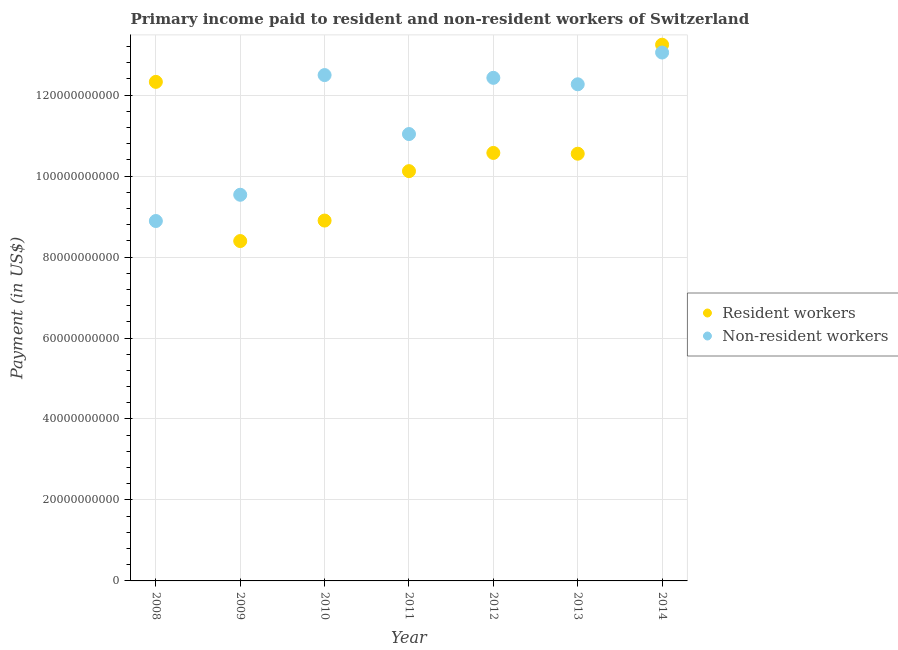What is the payment made to non-resident workers in 2013?
Provide a short and direct response. 1.23e+11. Across all years, what is the maximum payment made to resident workers?
Provide a short and direct response. 1.32e+11. Across all years, what is the minimum payment made to non-resident workers?
Offer a terse response. 8.89e+1. In which year was the payment made to non-resident workers minimum?
Make the answer very short. 2008. What is the total payment made to resident workers in the graph?
Ensure brevity in your answer.  7.41e+11. What is the difference between the payment made to non-resident workers in 2011 and that in 2012?
Your response must be concise. -1.39e+1. What is the difference between the payment made to resident workers in 2011 and the payment made to non-resident workers in 2012?
Your answer should be very brief. -2.31e+1. What is the average payment made to resident workers per year?
Provide a short and direct response. 1.06e+11. In the year 2011, what is the difference between the payment made to resident workers and payment made to non-resident workers?
Make the answer very short. -9.16e+09. What is the ratio of the payment made to resident workers in 2011 to that in 2012?
Keep it short and to the point. 0.96. Is the payment made to resident workers in 2013 less than that in 2014?
Offer a terse response. Yes. What is the difference between the highest and the second highest payment made to non-resident workers?
Offer a very short reply. 5.57e+09. What is the difference between the highest and the lowest payment made to resident workers?
Provide a succinct answer. 4.85e+1. Does the payment made to resident workers monotonically increase over the years?
Your response must be concise. No. How many years are there in the graph?
Your answer should be very brief. 7. Are the values on the major ticks of Y-axis written in scientific E-notation?
Ensure brevity in your answer.  No. What is the title of the graph?
Your response must be concise. Primary income paid to resident and non-resident workers of Switzerland. Does "National Visitors" appear as one of the legend labels in the graph?
Your answer should be compact. No. What is the label or title of the X-axis?
Provide a succinct answer. Year. What is the label or title of the Y-axis?
Provide a short and direct response. Payment (in US$). What is the Payment (in US$) of Resident workers in 2008?
Ensure brevity in your answer.  1.23e+11. What is the Payment (in US$) in Non-resident workers in 2008?
Offer a very short reply. 8.89e+1. What is the Payment (in US$) in Resident workers in 2009?
Make the answer very short. 8.40e+1. What is the Payment (in US$) of Non-resident workers in 2009?
Keep it short and to the point. 9.54e+1. What is the Payment (in US$) in Resident workers in 2010?
Ensure brevity in your answer.  8.90e+1. What is the Payment (in US$) in Non-resident workers in 2010?
Give a very brief answer. 1.25e+11. What is the Payment (in US$) in Resident workers in 2011?
Your response must be concise. 1.01e+11. What is the Payment (in US$) of Non-resident workers in 2011?
Provide a succinct answer. 1.10e+11. What is the Payment (in US$) of Resident workers in 2012?
Provide a succinct answer. 1.06e+11. What is the Payment (in US$) in Non-resident workers in 2012?
Keep it short and to the point. 1.24e+11. What is the Payment (in US$) in Resident workers in 2013?
Your response must be concise. 1.06e+11. What is the Payment (in US$) of Non-resident workers in 2013?
Ensure brevity in your answer.  1.23e+11. What is the Payment (in US$) in Resident workers in 2014?
Your answer should be compact. 1.32e+11. What is the Payment (in US$) of Non-resident workers in 2014?
Keep it short and to the point. 1.31e+11. Across all years, what is the maximum Payment (in US$) of Resident workers?
Provide a short and direct response. 1.32e+11. Across all years, what is the maximum Payment (in US$) of Non-resident workers?
Your response must be concise. 1.31e+11. Across all years, what is the minimum Payment (in US$) of Resident workers?
Ensure brevity in your answer.  8.40e+1. Across all years, what is the minimum Payment (in US$) of Non-resident workers?
Keep it short and to the point. 8.89e+1. What is the total Payment (in US$) in Resident workers in the graph?
Give a very brief answer. 7.41e+11. What is the total Payment (in US$) of Non-resident workers in the graph?
Provide a succinct answer. 7.97e+11. What is the difference between the Payment (in US$) in Resident workers in 2008 and that in 2009?
Your response must be concise. 3.93e+1. What is the difference between the Payment (in US$) in Non-resident workers in 2008 and that in 2009?
Keep it short and to the point. -6.48e+09. What is the difference between the Payment (in US$) of Resident workers in 2008 and that in 2010?
Your answer should be compact. 3.43e+1. What is the difference between the Payment (in US$) of Non-resident workers in 2008 and that in 2010?
Offer a terse response. -3.60e+1. What is the difference between the Payment (in US$) of Resident workers in 2008 and that in 2011?
Make the answer very short. 2.21e+1. What is the difference between the Payment (in US$) of Non-resident workers in 2008 and that in 2011?
Provide a short and direct response. -2.15e+1. What is the difference between the Payment (in US$) of Resident workers in 2008 and that in 2012?
Your response must be concise. 1.76e+1. What is the difference between the Payment (in US$) of Non-resident workers in 2008 and that in 2012?
Provide a short and direct response. -3.54e+1. What is the difference between the Payment (in US$) of Resident workers in 2008 and that in 2013?
Your answer should be compact. 1.77e+1. What is the difference between the Payment (in US$) in Non-resident workers in 2008 and that in 2013?
Your answer should be compact. -3.38e+1. What is the difference between the Payment (in US$) of Resident workers in 2008 and that in 2014?
Offer a very short reply. -9.18e+09. What is the difference between the Payment (in US$) in Non-resident workers in 2008 and that in 2014?
Your answer should be compact. -4.16e+1. What is the difference between the Payment (in US$) in Resident workers in 2009 and that in 2010?
Provide a succinct answer. -5.06e+09. What is the difference between the Payment (in US$) of Non-resident workers in 2009 and that in 2010?
Your response must be concise. -2.96e+1. What is the difference between the Payment (in US$) of Resident workers in 2009 and that in 2011?
Provide a short and direct response. -1.73e+1. What is the difference between the Payment (in US$) in Non-resident workers in 2009 and that in 2011?
Offer a very short reply. -1.50e+1. What is the difference between the Payment (in US$) of Resident workers in 2009 and that in 2012?
Keep it short and to the point. -2.18e+1. What is the difference between the Payment (in US$) in Non-resident workers in 2009 and that in 2012?
Provide a short and direct response. -2.89e+1. What is the difference between the Payment (in US$) in Resident workers in 2009 and that in 2013?
Ensure brevity in your answer.  -2.16e+1. What is the difference between the Payment (in US$) of Non-resident workers in 2009 and that in 2013?
Keep it short and to the point. -2.73e+1. What is the difference between the Payment (in US$) in Resident workers in 2009 and that in 2014?
Your response must be concise. -4.85e+1. What is the difference between the Payment (in US$) in Non-resident workers in 2009 and that in 2014?
Keep it short and to the point. -3.51e+1. What is the difference between the Payment (in US$) in Resident workers in 2010 and that in 2011?
Your answer should be very brief. -1.22e+1. What is the difference between the Payment (in US$) in Non-resident workers in 2010 and that in 2011?
Your answer should be compact. 1.46e+1. What is the difference between the Payment (in US$) in Resident workers in 2010 and that in 2012?
Keep it short and to the point. -1.67e+1. What is the difference between the Payment (in US$) of Non-resident workers in 2010 and that in 2012?
Provide a succinct answer. 6.81e+08. What is the difference between the Payment (in US$) of Resident workers in 2010 and that in 2013?
Provide a succinct answer. -1.65e+1. What is the difference between the Payment (in US$) in Non-resident workers in 2010 and that in 2013?
Keep it short and to the point. 2.28e+09. What is the difference between the Payment (in US$) in Resident workers in 2010 and that in 2014?
Give a very brief answer. -4.34e+1. What is the difference between the Payment (in US$) of Non-resident workers in 2010 and that in 2014?
Provide a short and direct response. -5.57e+09. What is the difference between the Payment (in US$) in Resident workers in 2011 and that in 2012?
Ensure brevity in your answer.  -4.50e+09. What is the difference between the Payment (in US$) of Non-resident workers in 2011 and that in 2012?
Offer a very short reply. -1.39e+1. What is the difference between the Payment (in US$) in Resident workers in 2011 and that in 2013?
Your answer should be compact. -4.31e+09. What is the difference between the Payment (in US$) of Non-resident workers in 2011 and that in 2013?
Offer a terse response. -1.23e+1. What is the difference between the Payment (in US$) in Resident workers in 2011 and that in 2014?
Your answer should be very brief. -3.12e+1. What is the difference between the Payment (in US$) in Non-resident workers in 2011 and that in 2014?
Make the answer very short. -2.01e+1. What is the difference between the Payment (in US$) in Resident workers in 2012 and that in 2013?
Your answer should be very brief. 1.92e+08. What is the difference between the Payment (in US$) of Non-resident workers in 2012 and that in 2013?
Provide a short and direct response. 1.60e+09. What is the difference between the Payment (in US$) of Resident workers in 2012 and that in 2014?
Provide a succinct answer. -2.67e+1. What is the difference between the Payment (in US$) in Non-resident workers in 2012 and that in 2014?
Offer a very short reply. -6.25e+09. What is the difference between the Payment (in US$) of Resident workers in 2013 and that in 2014?
Offer a very short reply. -2.69e+1. What is the difference between the Payment (in US$) of Non-resident workers in 2013 and that in 2014?
Make the answer very short. -7.84e+09. What is the difference between the Payment (in US$) of Resident workers in 2008 and the Payment (in US$) of Non-resident workers in 2009?
Provide a succinct answer. 2.79e+1. What is the difference between the Payment (in US$) in Resident workers in 2008 and the Payment (in US$) in Non-resident workers in 2010?
Provide a succinct answer. -1.68e+09. What is the difference between the Payment (in US$) in Resident workers in 2008 and the Payment (in US$) in Non-resident workers in 2011?
Give a very brief answer. 1.29e+1. What is the difference between the Payment (in US$) of Resident workers in 2008 and the Payment (in US$) of Non-resident workers in 2012?
Ensure brevity in your answer.  -9.99e+08. What is the difference between the Payment (in US$) of Resident workers in 2008 and the Payment (in US$) of Non-resident workers in 2013?
Provide a succinct answer. 5.97e+08. What is the difference between the Payment (in US$) of Resident workers in 2008 and the Payment (in US$) of Non-resident workers in 2014?
Your answer should be very brief. -7.25e+09. What is the difference between the Payment (in US$) in Resident workers in 2009 and the Payment (in US$) in Non-resident workers in 2010?
Provide a short and direct response. -4.10e+1. What is the difference between the Payment (in US$) in Resident workers in 2009 and the Payment (in US$) in Non-resident workers in 2011?
Ensure brevity in your answer.  -2.64e+1. What is the difference between the Payment (in US$) in Resident workers in 2009 and the Payment (in US$) in Non-resident workers in 2012?
Provide a succinct answer. -4.03e+1. What is the difference between the Payment (in US$) of Resident workers in 2009 and the Payment (in US$) of Non-resident workers in 2013?
Offer a very short reply. -3.87e+1. What is the difference between the Payment (in US$) of Resident workers in 2009 and the Payment (in US$) of Non-resident workers in 2014?
Provide a succinct answer. -4.66e+1. What is the difference between the Payment (in US$) in Resident workers in 2010 and the Payment (in US$) in Non-resident workers in 2011?
Keep it short and to the point. -2.14e+1. What is the difference between the Payment (in US$) of Resident workers in 2010 and the Payment (in US$) of Non-resident workers in 2012?
Offer a very short reply. -3.53e+1. What is the difference between the Payment (in US$) in Resident workers in 2010 and the Payment (in US$) in Non-resident workers in 2013?
Offer a very short reply. -3.37e+1. What is the difference between the Payment (in US$) in Resident workers in 2010 and the Payment (in US$) in Non-resident workers in 2014?
Your response must be concise. -4.15e+1. What is the difference between the Payment (in US$) of Resident workers in 2011 and the Payment (in US$) of Non-resident workers in 2012?
Your answer should be very brief. -2.31e+1. What is the difference between the Payment (in US$) of Resident workers in 2011 and the Payment (in US$) of Non-resident workers in 2013?
Your answer should be very brief. -2.15e+1. What is the difference between the Payment (in US$) of Resident workers in 2011 and the Payment (in US$) of Non-resident workers in 2014?
Ensure brevity in your answer.  -2.93e+1. What is the difference between the Payment (in US$) in Resident workers in 2012 and the Payment (in US$) in Non-resident workers in 2013?
Your answer should be compact. -1.70e+1. What is the difference between the Payment (in US$) in Resident workers in 2012 and the Payment (in US$) in Non-resident workers in 2014?
Ensure brevity in your answer.  -2.48e+1. What is the difference between the Payment (in US$) in Resident workers in 2013 and the Payment (in US$) in Non-resident workers in 2014?
Keep it short and to the point. -2.50e+1. What is the average Payment (in US$) in Resident workers per year?
Your answer should be very brief. 1.06e+11. What is the average Payment (in US$) in Non-resident workers per year?
Give a very brief answer. 1.14e+11. In the year 2008, what is the difference between the Payment (in US$) in Resident workers and Payment (in US$) in Non-resident workers?
Make the answer very short. 3.44e+1. In the year 2009, what is the difference between the Payment (in US$) in Resident workers and Payment (in US$) in Non-resident workers?
Provide a short and direct response. -1.14e+1. In the year 2010, what is the difference between the Payment (in US$) in Resident workers and Payment (in US$) in Non-resident workers?
Offer a very short reply. -3.59e+1. In the year 2011, what is the difference between the Payment (in US$) of Resident workers and Payment (in US$) of Non-resident workers?
Make the answer very short. -9.16e+09. In the year 2012, what is the difference between the Payment (in US$) of Resident workers and Payment (in US$) of Non-resident workers?
Offer a terse response. -1.86e+1. In the year 2013, what is the difference between the Payment (in US$) of Resident workers and Payment (in US$) of Non-resident workers?
Your answer should be very brief. -1.71e+1. In the year 2014, what is the difference between the Payment (in US$) in Resident workers and Payment (in US$) in Non-resident workers?
Provide a succinct answer. 1.94e+09. What is the ratio of the Payment (in US$) of Resident workers in 2008 to that in 2009?
Ensure brevity in your answer.  1.47. What is the ratio of the Payment (in US$) in Non-resident workers in 2008 to that in 2009?
Provide a succinct answer. 0.93. What is the ratio of the Payment (in US$) of Resident workers in 2008 to that in 2010?
Make the answer very short. 1.38. What is the ratio of the Payment (in US$) in Non-resident workers in 2008 to that in 2010?
Your answer should be very brief. 0.71. What is the ratio of the Payment (in US$) of Resident workers in 2008 to that in 2011?
Ensure brevity in your answer.  1.22. What is the ratio of the Payment (in US$) of Non-resident workers in 2008 to that in 2011?
Make the answer very short. 0.81. What is the ratio of the Payment (in US$) of Resident workers in 2008 to that in 2012?
Make the answer very short. 1.17. What is the ratio of the Payment (in US$) in Non-resident workers in 2008 to that in 2012?
Keep it short and to the point. 0.72. What is the ratio of the Payment (in US$) in Resident workers in 2008 to that in 2013?
Keep it short and to the point. 1.17. What is the ratio of the Payment (in US$) of Non-resident workers in 2008 to that in 2013?
Provide a short and direct response. 0.72. What is the ratio of the Payment (in US$) of Resident workers in 2008 to that in 2014?
Make the answer very short. 0.93. What is the ratio of the Payment (in US$) of Non-resident workers in 2008 to that in 2014?
Offer a very short reply. 0.68. What is the ratio of the Payment (in US$) of Resident workers in 2009 to that in 2010?
Provide a succinct answer. 0.94. What is the ratio of the Payment (in US$) of Non-resident workers in 2009 to that in 2010?
Make the answer very short. 0.76. What is the ratio of the Payment (in US$) in Resident workers in 2009 to that in 2011?
Ensure brevity in your answer.  0.83. What is the ratio of the Payment (in US$) in Non-resident workers in 2009 to that in 2011?
Give a very brief answer. 0.86. What is the ratio of the Payment (in US$) in Resident workers in 2009 to that in 2012?
Offer a very short reply. 0.79. What is the ratio of the Payment (in US$) in Non-resident workers in 2009 to that in 2012?
Give a very brief answer. 0.77. What is the ratio of the Payment (in US$) of Resident workers in 2009 to that in 2013?
Make the answer very short. 0.8. What is the ratio of the Payment (in US$) of Non-resident workers in 2009 to that in 2013?
Provide a short and direct response. 0.78. What is the ratio of the Payment (in US$) of Resident workers in 2009 to that in 2014?
Provide a succinct answer. 0.63. What is the ratio of the Payment (in US$) in Non-resident workers in 2009 to that in 2014?
Give a very brief answer. 0.73. What is the ratio of the Payment (in US$) in Resident workers in 2010 to that in 2011?
Offer a terse response. 0.88. What is the ratio of the Payment (in US$) of Non-resident workers in 2010 to that in 2011?
Provide a short and direct response. 1.13. What is the ratio of the Payment (in US$) of Resident workers in 2010 to that in 2012?
Ensure brevity in your answer.  0.84. What is the ratio of the Payment (in US$) in Non-resident workers in 2010 to that in 2012?
Keep it short and to the point. 1.01. What is the ratio of the Payment (in US$) in Resident workers in 2010 to that in 2013?
Provide a succinct answer. 0.84. What is the ratio of the Payment (in US$) of Non-resident workers in 2010 to that in 2013?
Ensure brevity in your answer.  1.02. What is the ratio of the Payment (in US$) in Resident workers in 2010 to that in 2014?
Keep it short and to the point. 0.67. What is the ratio of the Payment (in US$) in Non-resident workers in 2010 to that in 2014?
Give a very brief answer. 0.96. What is the ratio of the Payment (in US$) in Resident workers in 2011 to that in 2012?
Make the answer very short. 0.96. What is the ratio of the Payment (in US$) in Non-resident workers in 2011 to that in 2012?
Provide a short and direct response. 0.89. What is the ratio of the Payment (in US$) in Resident workers in 2011 to that in 2013?
Your response must be concise. 0.96. What is the ratio of the Payment (in US$) in Non-resident workers in 2011 to that in 2013?
Provide a short and direct response. 0.9. What is the ratio of the Payment (in US$) of Resident workers in 2011 to that in 2014?
Give a very brief answer. 0.76. What is the ratio of the Payment (in US$) in Non-resident workers in 2011 to that in 2014?
Make the answer very short. 0.85. What is the ratio of the Payment (in US$) in Resident workers in 2012 to that in 2014?
Provide a succinct answer. 0.8. What is the ratio of the Payment (in US$) of Non-resident workers in 2012 to that in 2014?
Ensure brevity in your answer.  0.95. What is the ratio of the Payment (in US$) of Resident workers in 2013 to that in 2014?
Your answer should be compact. 0.8. What is the ratio of the Payment (in US$) in Non-resident workers in 2013 to that in 2014?
Ensure brevity in your answer.  0.94. What is the difference between the highest and the second highest Payment (in US$) in Resident workers?
Your response must be concise. 9.18e+09. What is the difference between the highest and the second highest Payment (in US$) in Non-resident workers?
Ensure brevity in your answer.  5.57e+09. What is the difference between the highest and the lowest Payment (in US$) in Resident workers?
Your answer should be very brief. 4.85e+1. What is the difference between the highest and the lowest Payment (in US$) of Non-resident workers?
Offer a terse response. 4.16e+1. 